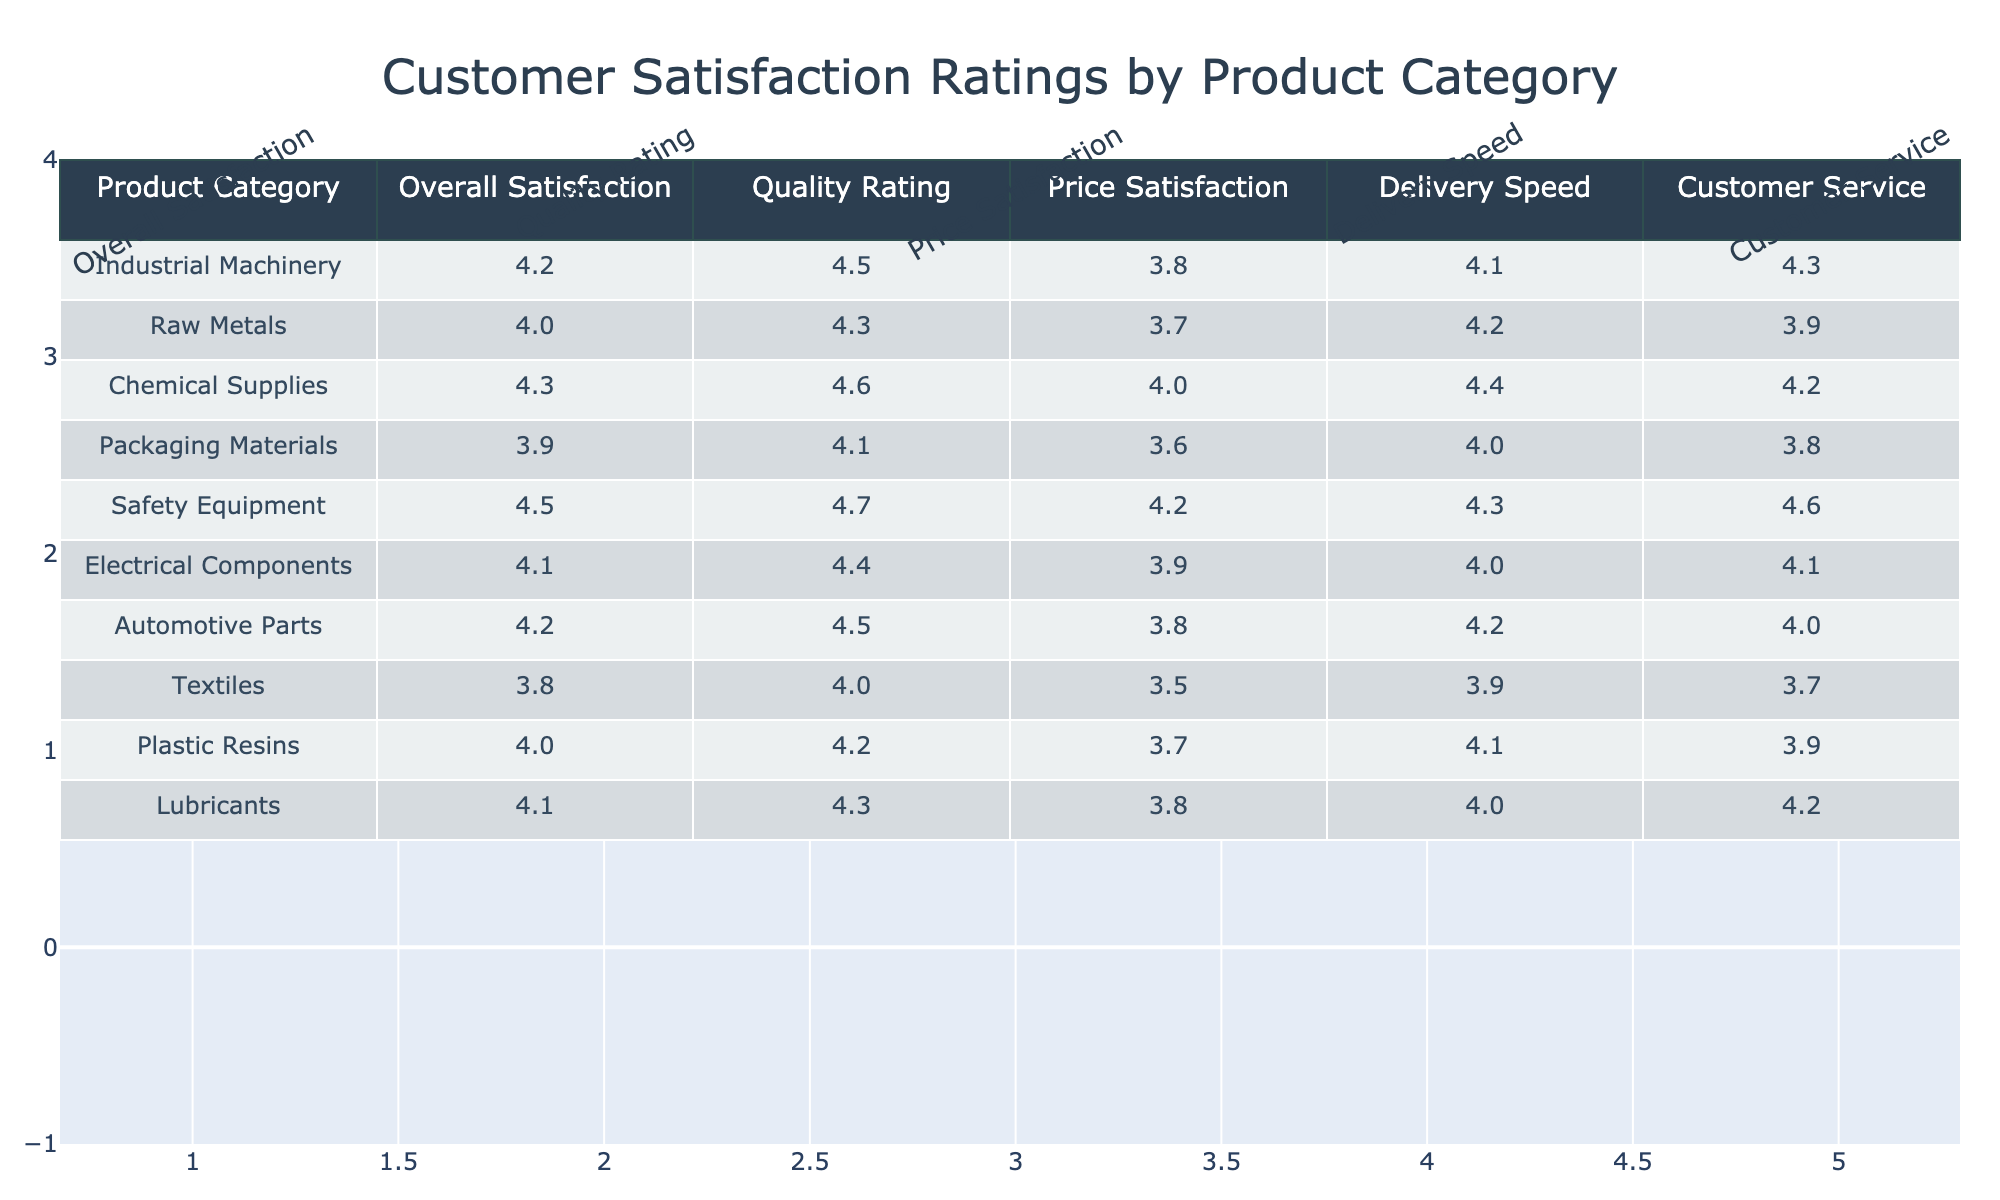What is the overall satisfaction rating for Safety Equipment? The table shows the overall satisfaction rating for Safety Equipment is listed under the respective column. The value found there is 4.5.
Answer: 4.5 Which product category has the highest Quality Rating? By inspecting the Quality Rating column, I can see that Safety Equipment has the highest value of 4.7.
Answer: Safety Equipment What is the average Price Satisfaction across all product categories? To find the average Price Satisfaction, I sum all the values in the Price Satisfaction column (3.8 + 3.7 + 4.0 + 3.6 + 4.2 + 3.9 + 3.8 + 3.5 + 3.7 + 3.8) = 37.0. Then, I divide by the number of product categories (10), resulting in an average of 3.7.
Answer: 3.7 Is the Delivery Speed rating for Raw Metals greater than or equal to 4.0? Looking up the Delivery Speed rating for Raw Metals in the table, I find the value to be 4.2, which is indeed greater than 4.0.
Answer: Yes Which product category has the lowest Customer Service rating? I need to check the Customer Service ratings for all product categories. The lowest rating is found in Textiles, which has a 3.7, making it the lowest value.
Answer: Textiles What is the difference between the overall satisfaction ratings for Industrial Machinery and Electrical Components? The overall satisfaction rating for Industrial Machinery is 4.2, while for Electrical Components, it is 4.1. The difference is calculated as 4.2 - 4.1 = 0.1.
Answer: 0.1 Does any product category have a Quality Rating of 4.5 or higher? By reviewing the Quality Rating column, I observe that Industrial Machinery, Chemical Supplies, Safety Equipment, and Automotive Parts all have Quality Ratings of 4.5 or higher, confirming that there are indeed categories that meet this criterion.
Answer: Yes What is the median of the Delivery Speed ratings across the product categories? To find the median, I first arrange the Delivery Speed ratings from lowest to highest: 3.9, 4.0, 4.0, 4.1, 4.2, 4.2, 4.3, 4.3, 4.4, and 4.4. The median is the average of the 5th (4.2) and 6th (4.2) values, so it’s (4.2 + 4.2) / 2 = 4.2.
Answer: 4.2 How does the overall satisfaction rating for Chemical Supplies compare to that of Raw Metals? The overall satisfaction rating for Chemical Supplies is 4.3 and for Raw Metals, it is 4.0. Since 4.3 is greater than 4.0, Chemical Supplies has a higher rating compared to Raw Metals.
Answer: Chemical Supplies is higher 